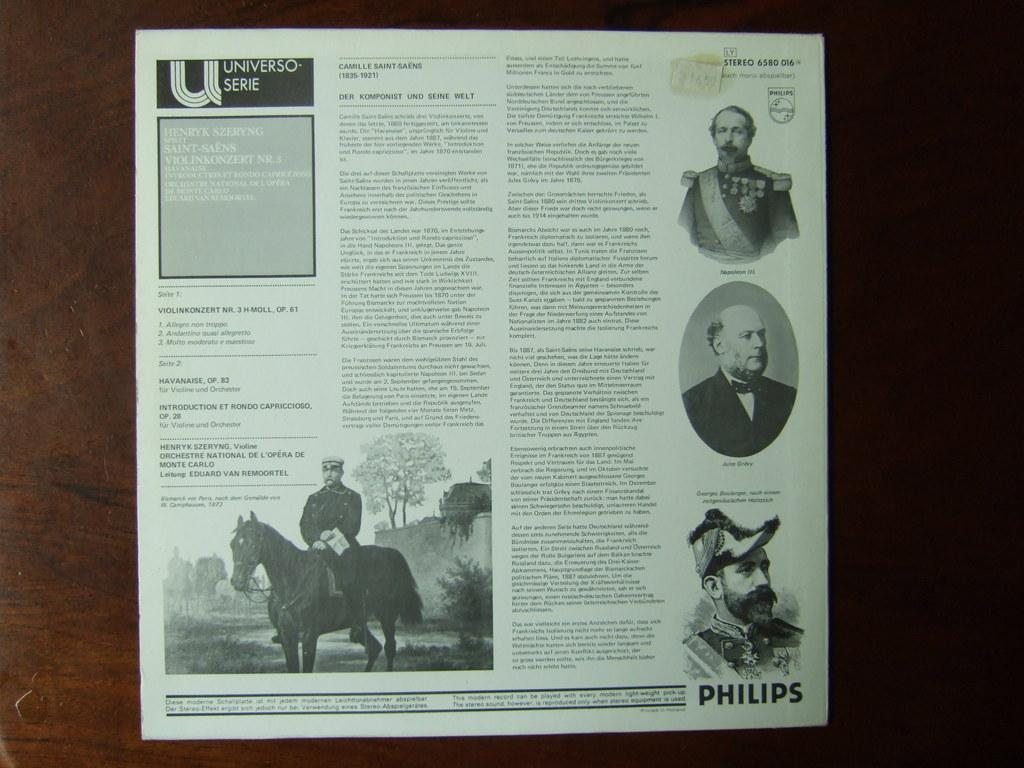What is hanging on the wall in the image? There is an article on the wall in the image. How many pairs of shoes can be seen on the visitor in the image? There is no visitor or shoes present in the image; it only features an article on the wall. 